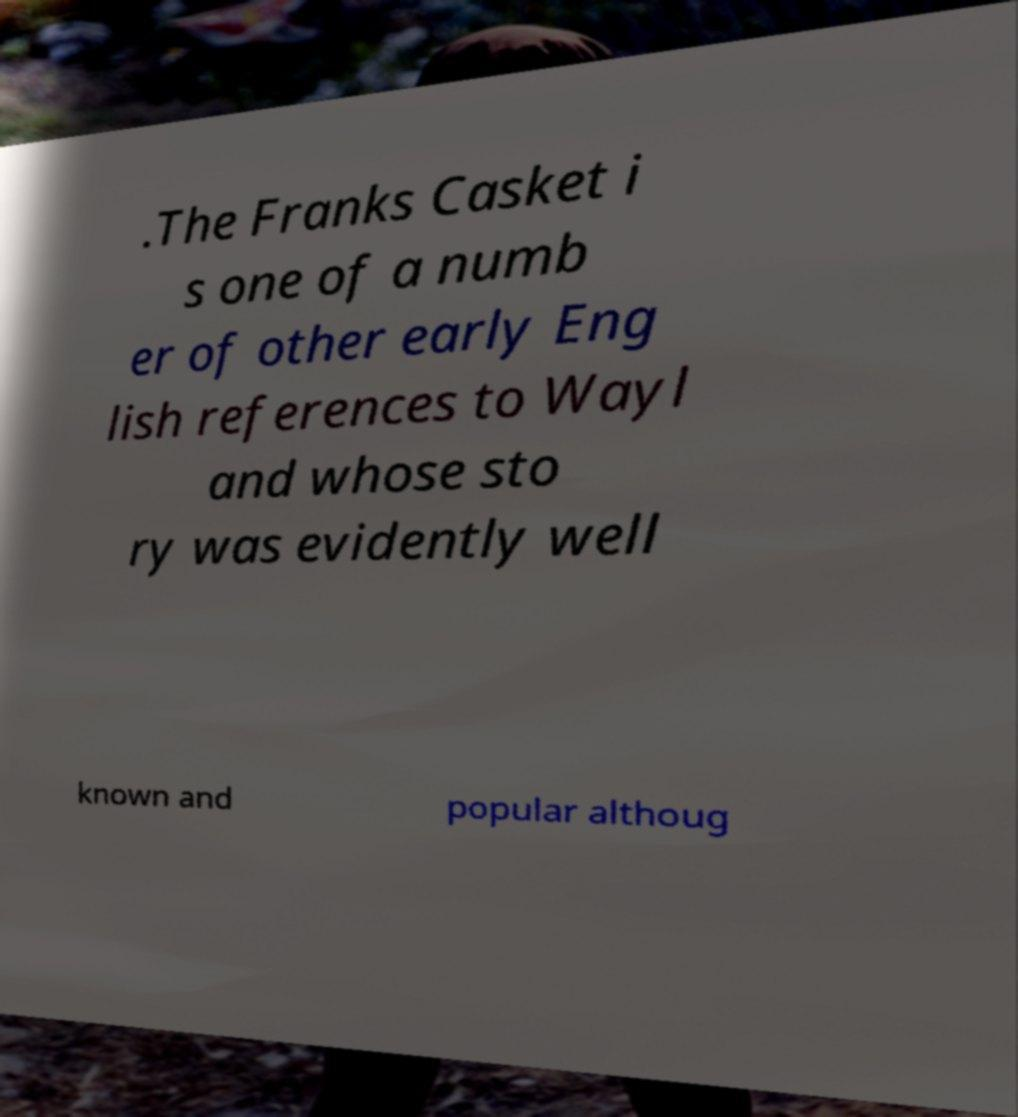What messages or text are displayed in this image? I need them in a readable, typed format. .The Franks Casket i s one of a numb er of other early Eng lish references to Wayl and whose sto ry was evidently well known and popular althoug 